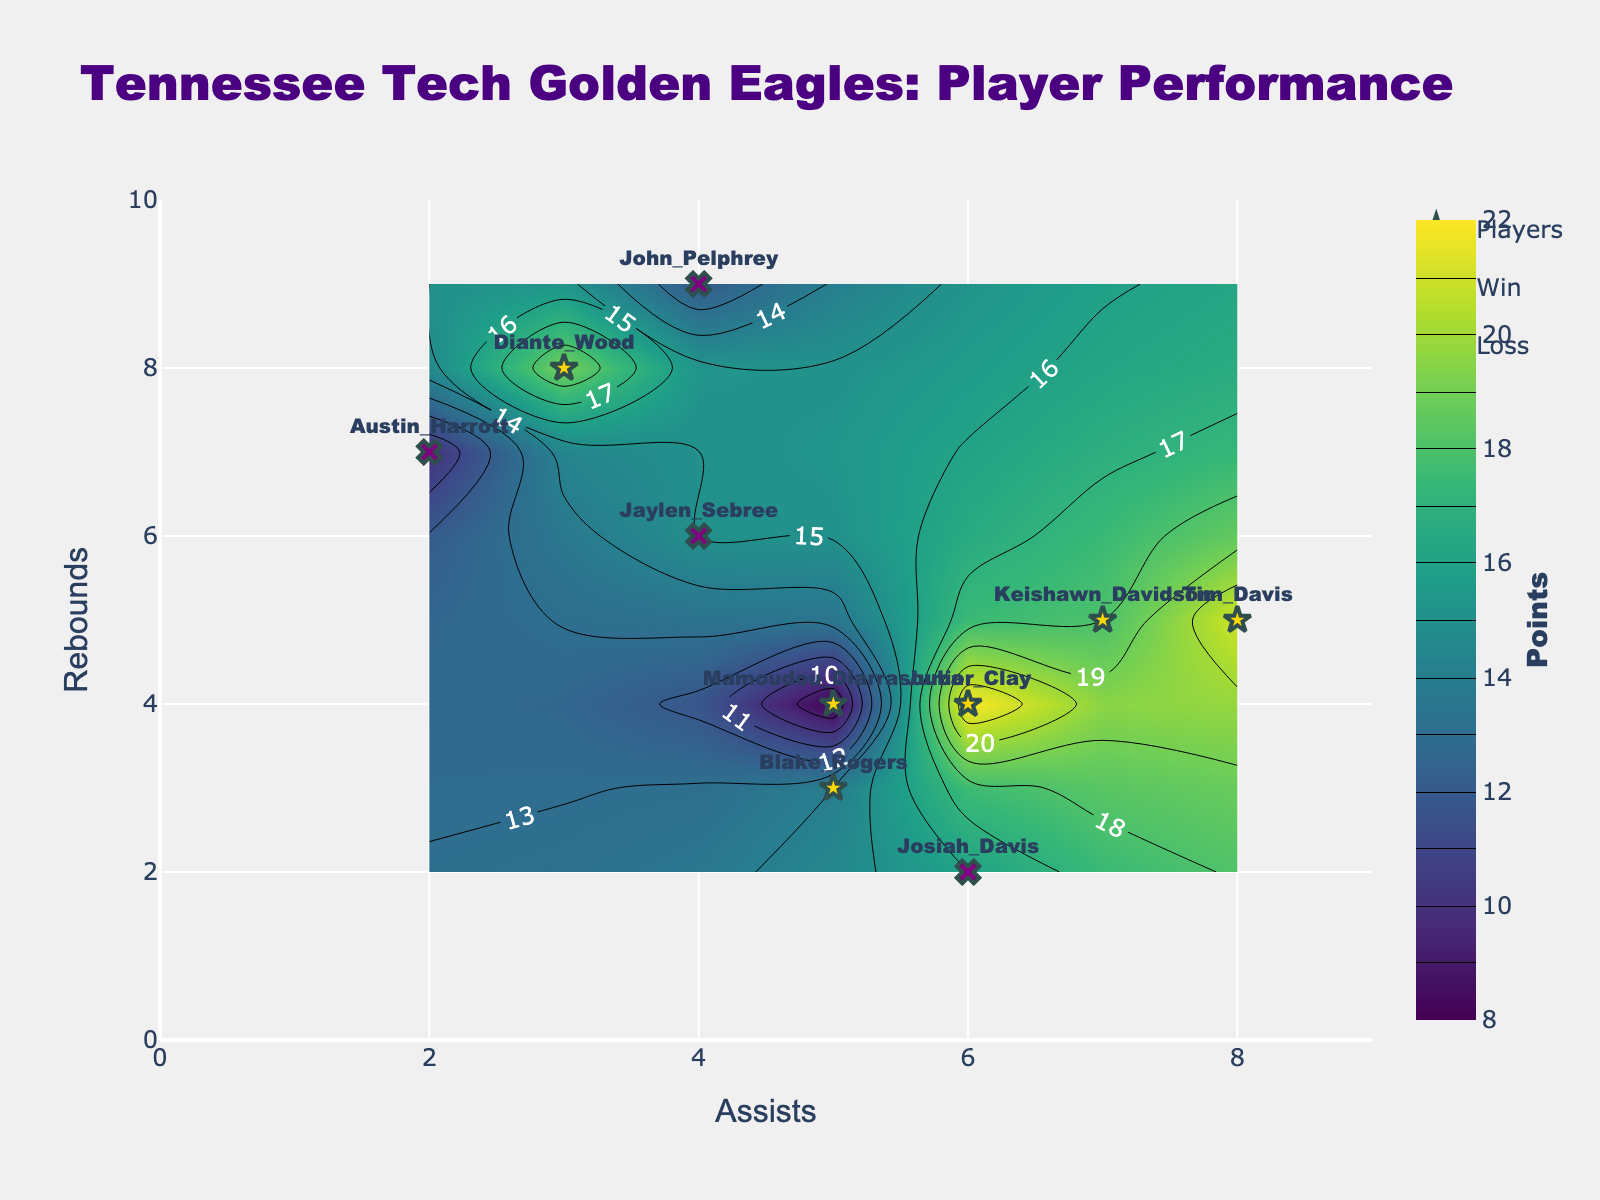What is the title of the plot? The title of the plot is clearly labeled at the top of the figure. It reads "Tennessee Tech Golden Eagles: Player Performance".
Answer: Tennessee Tech Golden Eagles: Player Performance What do the colors of the contour plot represent? The contour plot has a color bar on the right labeled "Points". Therefore, the colors in the contour plot represent the number of points scored by the players.
Answer: Points scored Which player has the highest assists and what is their outcome? From the scatter plot, look for the player placed farthest to the right. Tim Davis has the highest assists with a value of 8. His marker is gold, indicating a win.
Answer: Tim Davis, Win How many players had more than 6 rebounds in their games? Identify the players above the y-axis value of 6. The players are Austin Harrott, Diante Wood, and John Pelphrey, making a total of 3 players.
Answer: 3 Which player had the fewest points among those who won? Look for the gold markers to identify the players who won. Among these markers, check the number associated with the "Points" on the contour. Mamoudou Diarrasouba had the fewest points (8) among the winners.
Answer: Mamoudou Diarrasouba What is the sum of points scored by players with more than 5 assists? Identify players with more than 5 assists (Keishawn Davidson, Junior Clay, Josiah Davis, Tim Davis). Sum up their points: 18 + 22 + 16 + 21 = 77.
Answer: 77 Who had a better performance in terms of rebounds: Jaylen Sebree or Keishawn Davidson? Compare the y-axis positions of Jaylen Sebree and Keishawn Davidson. Jaylen Sebree (6 rebounds) is slightly higher than Keishawn Davidson (5 rebounds).
Answer: Jaylen Sebree Which players had the same assists and who had better points among them? Keishawn Davidson and Tim Davis both have 8 assists. Among them, Tim Davis scored more points (21) compared to Keishawn Davidson (18).
Answer: Tim Davis Are there more players marked with gold or purple in the figure? Count the gold markers (Win) and purple markers (Loss). Gold markers: 5 (winners). Purple markers: 4 (losers). So there are more players marked with gold.
Answer: Gold How often do players with more than 4 rebounds win their games? Look at players with more than 4 rebounds (points on the y-axis greater than 4). These are Keishawn Davidson, Jaylen Sebree, Austin Harrott, Diante Wood, John Pelphrey. Out of these, Keishawn Davidson, Diante Wood won. So, 2 out of 5 times.
Answer: 2 out of 5 times 